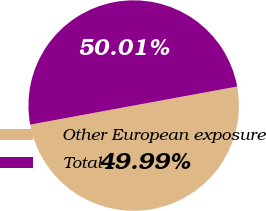Convert chart to OTSL. <chart><loc_0><loc_0><loc_500><loc_500><pie_chart><fcel>Other European exposure<fcel>Total<nl><fcel>49.99%<fcel>50.01%<nl></chart> 